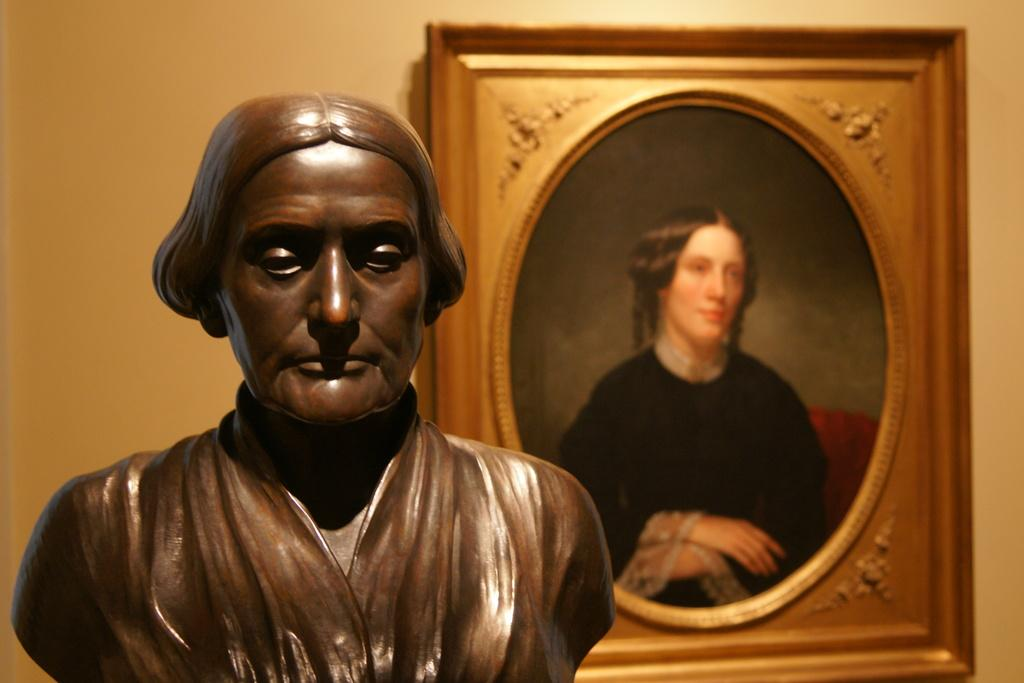What is the main subject of the image? There is a brown-colored sculpture in the image. What can be seen in the background of the image? There is a frame and a depiction of a person in the background of the image. What time of day is represented by the sculpture in the image? The sculpture does not represent a specific time of day; it is a static object. 